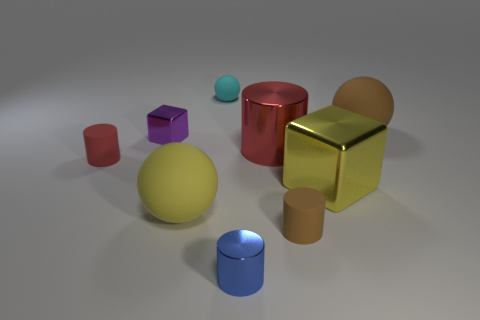Subtract all balls. How many objects are left? 6 Add 1 tiny brown matte things. How many objects exist? 10 Subtract all tiny purple cubes. Subtract all red rubber objects. How many objects are left? 7 Add 4 big yellow spheres. How many big yellow spheres are left? 5 Add 1 large blue objects. How many large blue objects exist? 1 Subtract 0 brown cubes. How many objects are left? 9 